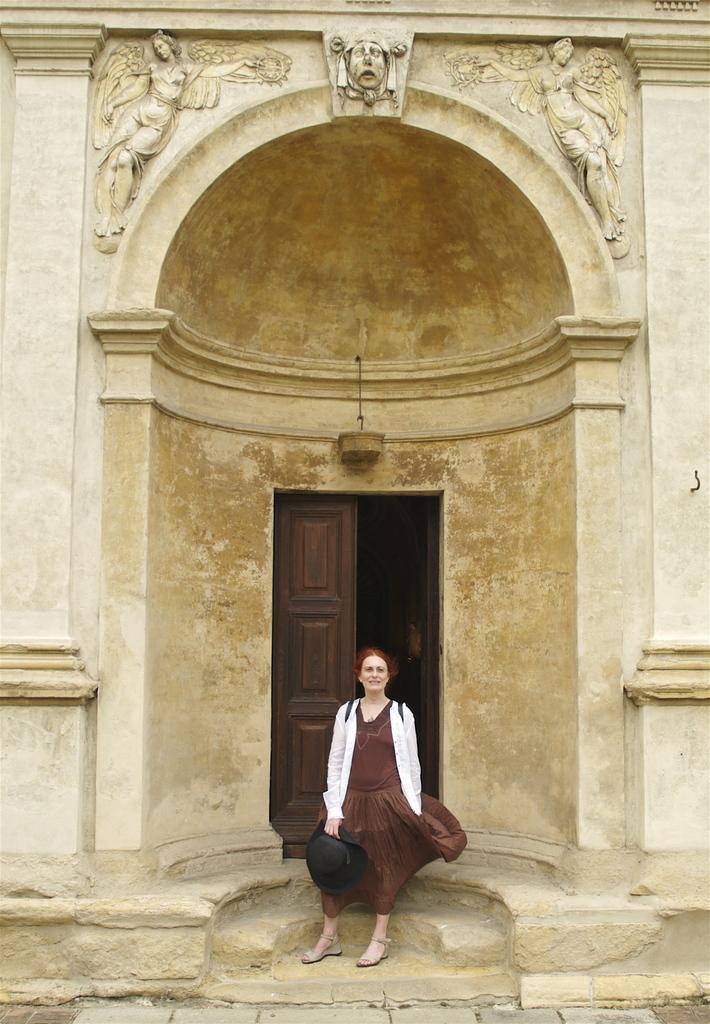Could you give a brief overview of what you see in this image? In this picture we can see a building, door, roof and carving on the wall. At the bottom of the image we can see the stairs, ground and a lady is standing and wearing coat, bag and holding a hat. 